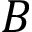<formula> <loc_0><loc_0><loc_500><loc_500>B</formula> 